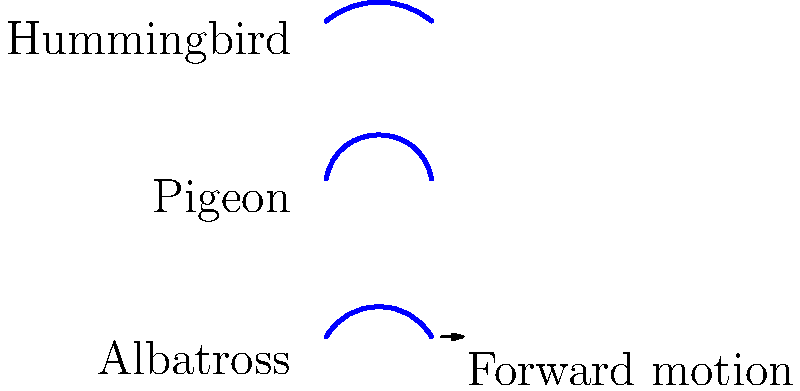As an illustrator familiar with animal anatomy, compare the wing flapping motion of a hummingbird, pigeon, and albatross as shown in the diagram. Which bird's wing motion is most efficient for long-distance flight, and why? To answer this question, let's analyze the wing motion of each bird:

1. Hummingbird (top path):
   - Shows a steep, almost vertical wing motion
   - Indicates rapid flapping with a high angle of attack
   - Efficient for hovering and quick maneuvers, but energy-intensive

2. Pigeon (middle path):
   - Displays a moderate wing motion angle
   - Balances lift and forward thrust
   - Suitable for medium-distance flights in various conditions

3. Albatross (bottom path):
   - Exhibits a shallow wing motion angle
   - Maximizes forward gliding motion with minimal vertical movement
   - Ideal for long-distance flights over open water

For long-distance flight efficiency, we need to consider:
a) Energy conservation
b) Forward motion maximization
c) Lift generation

The albatross's wing motion is most efficient for long-distance flight because:
1. It minimizes energy expenditure by reducing the frequency and amplitude of wing beats
2. The shallow angle maximizes forward gliding motion, allowing the bird to cover great distances with minimal effort
3. Albatrosses can exploit wind currents and air pressure differences over the ocean surface (dynamic soaring) to maintain lift and speed with infrequent wing beats

This efficient flight mechanism allows albatrosses to travel thousands of kilometers with minimal energy consumption, making them perfectly adapted for long-distance flights over open oceans.
Answer: Albatross, due to shallow wing motion maximizing gliding and energy conservation. 